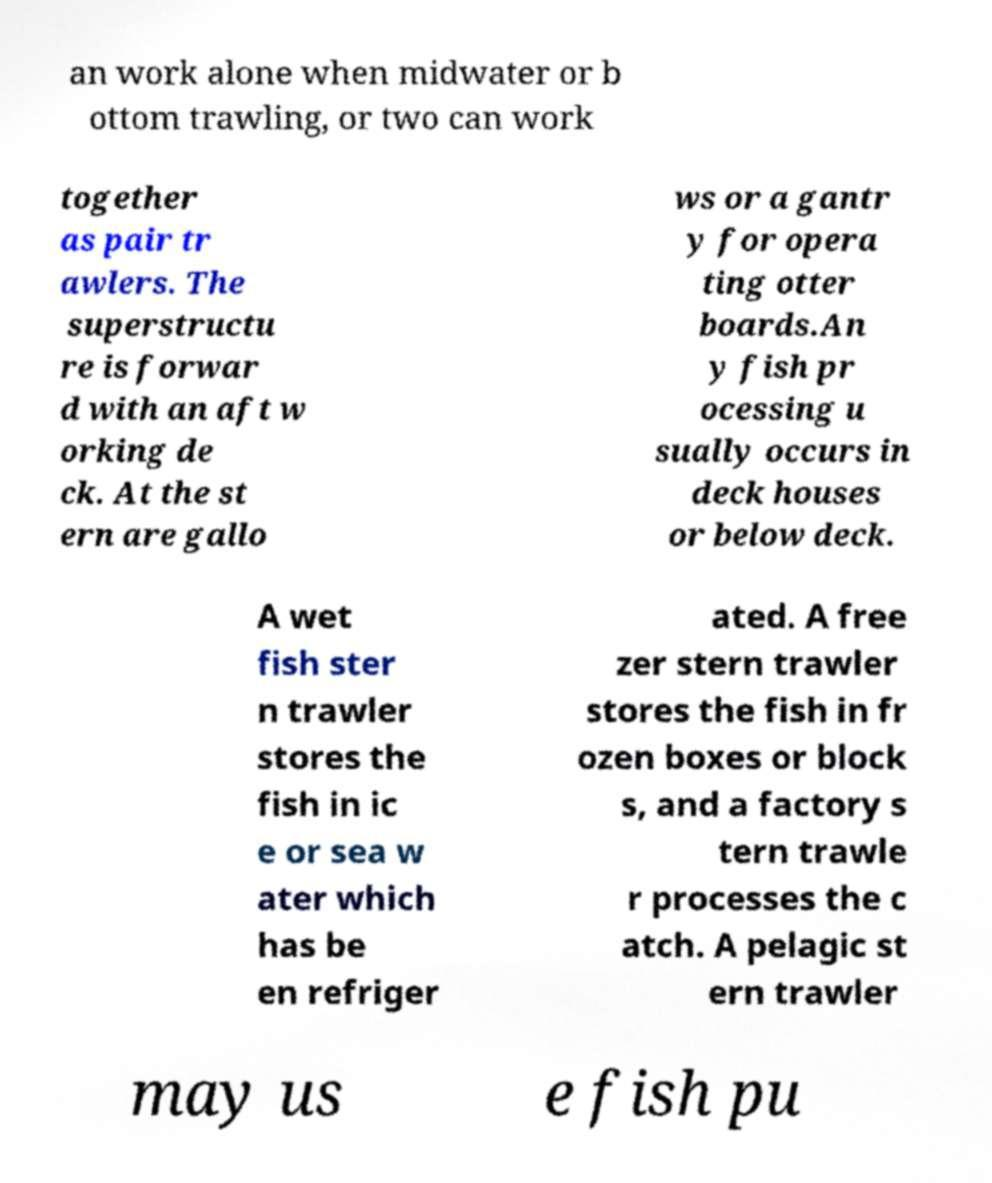For documentation purposes, I need the text within this image transcribed. Could you provide that? an work alone when midwater or b ottom trawling, or two can work together as pair tr awlers. The superstructu re is forwar d with an aft w orking de ck. At the st ern are gallo ws or a gantr y for opera ting otter boards.An y fish pr ocessing u sually occurs in deck houses or below deck. A wet fish ster n trawler stores the fish in ic e or sea w ater which has be en refriger ated. A free zer stern trawler stores the fish in fr ozen boxes or block s, and a factory s tern trawle r processes the c atch. A pelagic st ern trawler may us e fish pu 